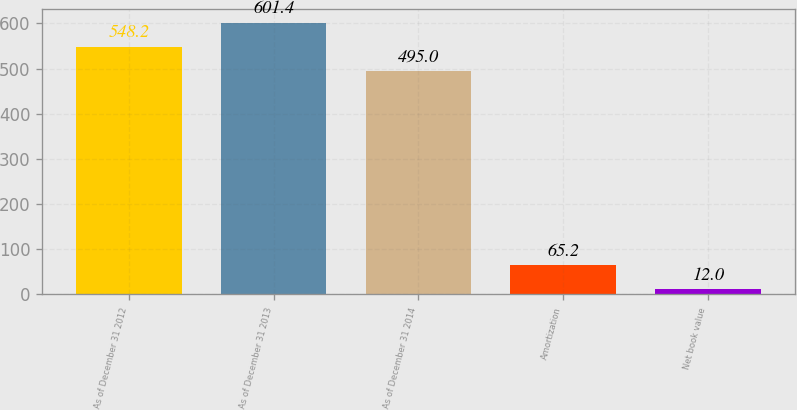Convert chart to OTSL. <chart><loc_0><loc_0><loc_500><loc_500><bar_chart><fcel>As of December 31 2012<fcel>As of December 31 2013<fcel>As of December 31 2014<fcel>Amortization<fcel>Net book value<nl><fcel>548.2<fcel>601.4<fcel>495<fcel>65.2<fcel>12<nl></chart> 